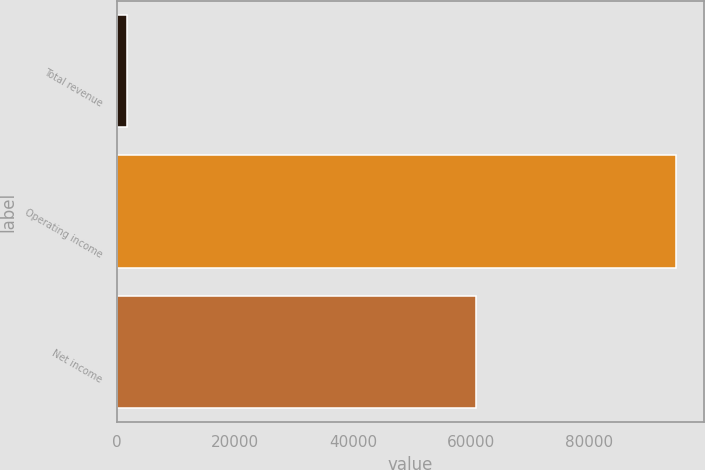<chart> <loc_0><loc_0><loc_500><loc_500><bar_chart><fcel>Total revenue<fcel>Operating income<fcel>Net income<nl><fcel>1725<fcel>94665<fcel>60854<nl></chart> 